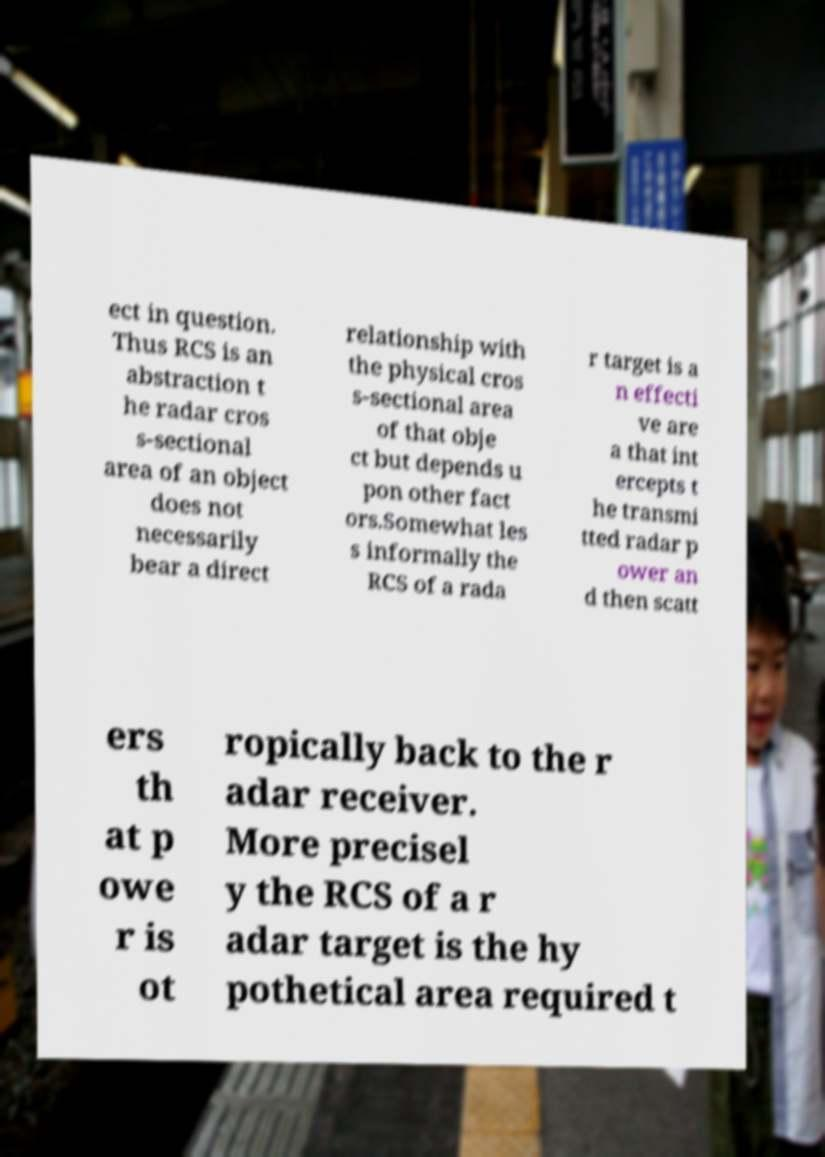I need the written content from this picture converted into text. Can you do that? ect in question. Thus RCS is an abstraction t he radar cros s-sectional area of an object does not necessarily bear a direct relationship with the physical cros s-sectional area of that obje ct but depends u pon other fact ors.Somewhat les s informally the RCS of a rada r target is a n effecti ve are a that int ercepts t he transmi tted radar p ower an d then scatt ers th at p owe r is ot ropically back to the r adar receiver. More precisel y the RCS of a r adar target is the hy pothetical area required t 